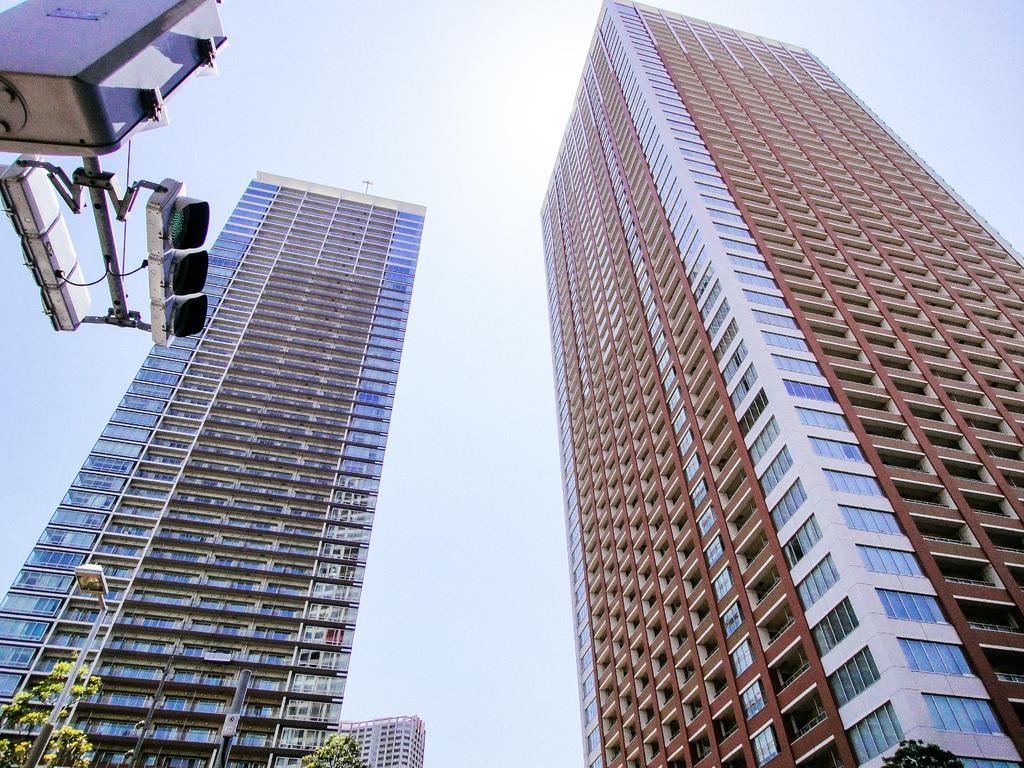Please provide a concise description of this image. In this image, we can see buildings. There is a street pole in the bottom left of the image. There is a signal light in the top left of the image. In the background of the image, there is a sky. 